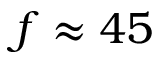<formula> <loc_0><loc_0><loc_500><loc_500>f \approx 4 5</formula> 